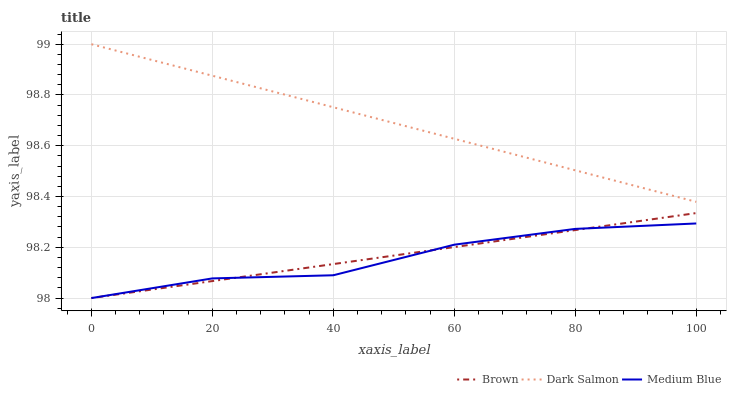Does Medium Blue have the minimum area under the curve?
Answer yes or no. Yes. Does Dark Salmon have the maximum area under the curve?
Answer yes or no. Yes. Does Dark Salmon have the minimum area under the curve?
Answer yes or no. No. Does Medium Blue have the maximum area under the curve?
Answer yes or no. No. Is Brown the smoothest?
Answer yes or no. Yes. Is Medium Blue the roughest?
Answer yes or no. Yes. Is Dark Salmon the smoothest?
Answer yes or no. No. Is Dark Salmon the roughest?
Answer yes or no. No. Does Brown have the lowest value?
Answer yes or no. Yes. Does Dark Salmon have the lowest value?
Answer yes or no. No. Does Dark Salmon have the highest value?
Answer yes or no. Yes. Does Medium Blue have the highest value?
Answer yes or no. No. Is Medium Blue less than Dark Salmon?
Answer yes or no. Yes. Is Dark Salmon greater than Medium Blue?
Answer yes or no. Yes. Does Medium Blue intersect Brown?
Answer yes or no. Yes. Is Medium Blue less than Brown?
Answer yes or no. No. Is Medium Blue greater than Brown?
Answer yes or no. No. Does Medium Blue intersect Dark Salmon?
Answer yes or no. No. 